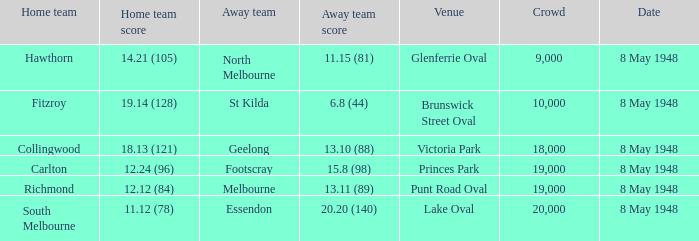Which away team has a home score of 14.21 (105)? North Melbourne. 